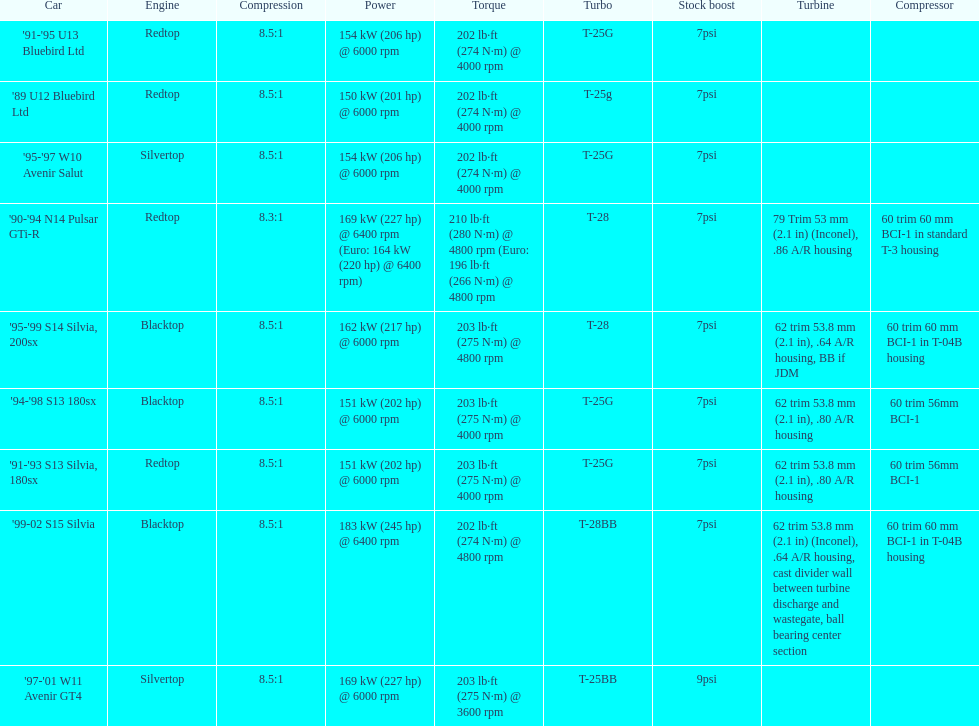How many models used the redtop engine? 4. 